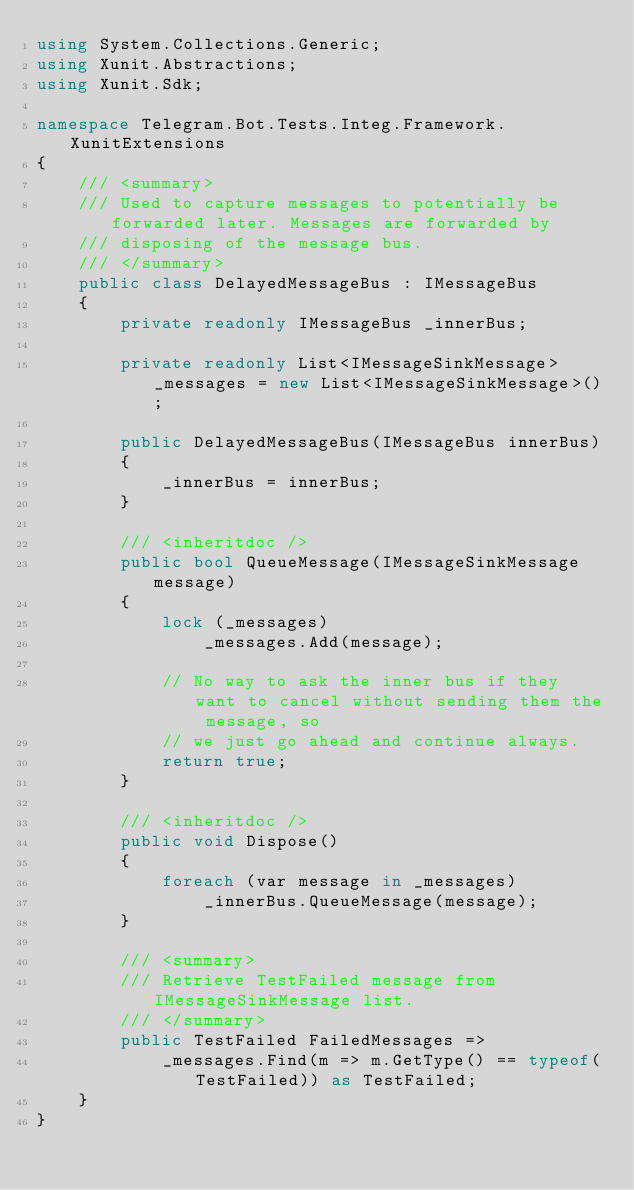<code> <loc_0><loc_0><loc_500><loc_500><_C#_>using System.Collections.Generic;
using Xunit.Abstractions;
using Xunit.Sdk;

namespace Telegram.Bot.Tests.Integ.Framework.XunitExtensions
{
    /// <summary>
    /// Used to capture messages to potentially be forwarded later. Messages are forwarded by
    /// disposing of the message bus.
    /// </summary>
    public class DelayedMessageBus : IMessageBus
    {
        private readonly IMessageBus _innerBus;

        private readonly List<IMessageSinkMessage> _messages = new List<IMessageSinkMessage>();

        public DelayedMessageBus(IMessageBus innerBus)
        {
            _innerBus = innerBus;
        }

        /// <inheritdoc />
        public bool QueueMessage(IMessageSinkMessage message)
        {
            lock (_messages)
                _messages.Add(message);

            // No way to ask the inner bus if they want to cancel without sending them the message, so
            // we just go ahead and continue always.
            return true;
        }

        /// <inheritdoc />
        public void Dispose()
        {
            foreach (var message in _messages)
                _innerBus.QueueMessage(message);
        }

        /// <summary>
        /// Retrieve TestFailed message from IMessageSinkMessage list.
        /// </summary>
        public TestFailed FailedMessages =>
            _messages.Find(m => m.GetType() == typeof(TestFailed)) as TestFailed;
    }
}
</code> 